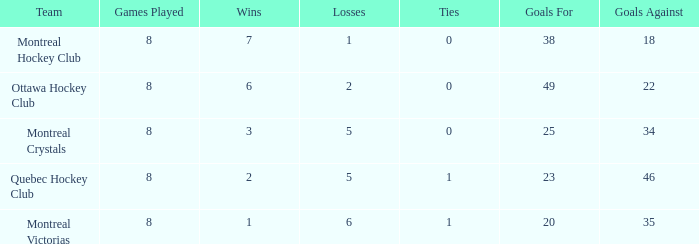What is the average ties when the team is montreal victorias and the games played is more than 8? None. 